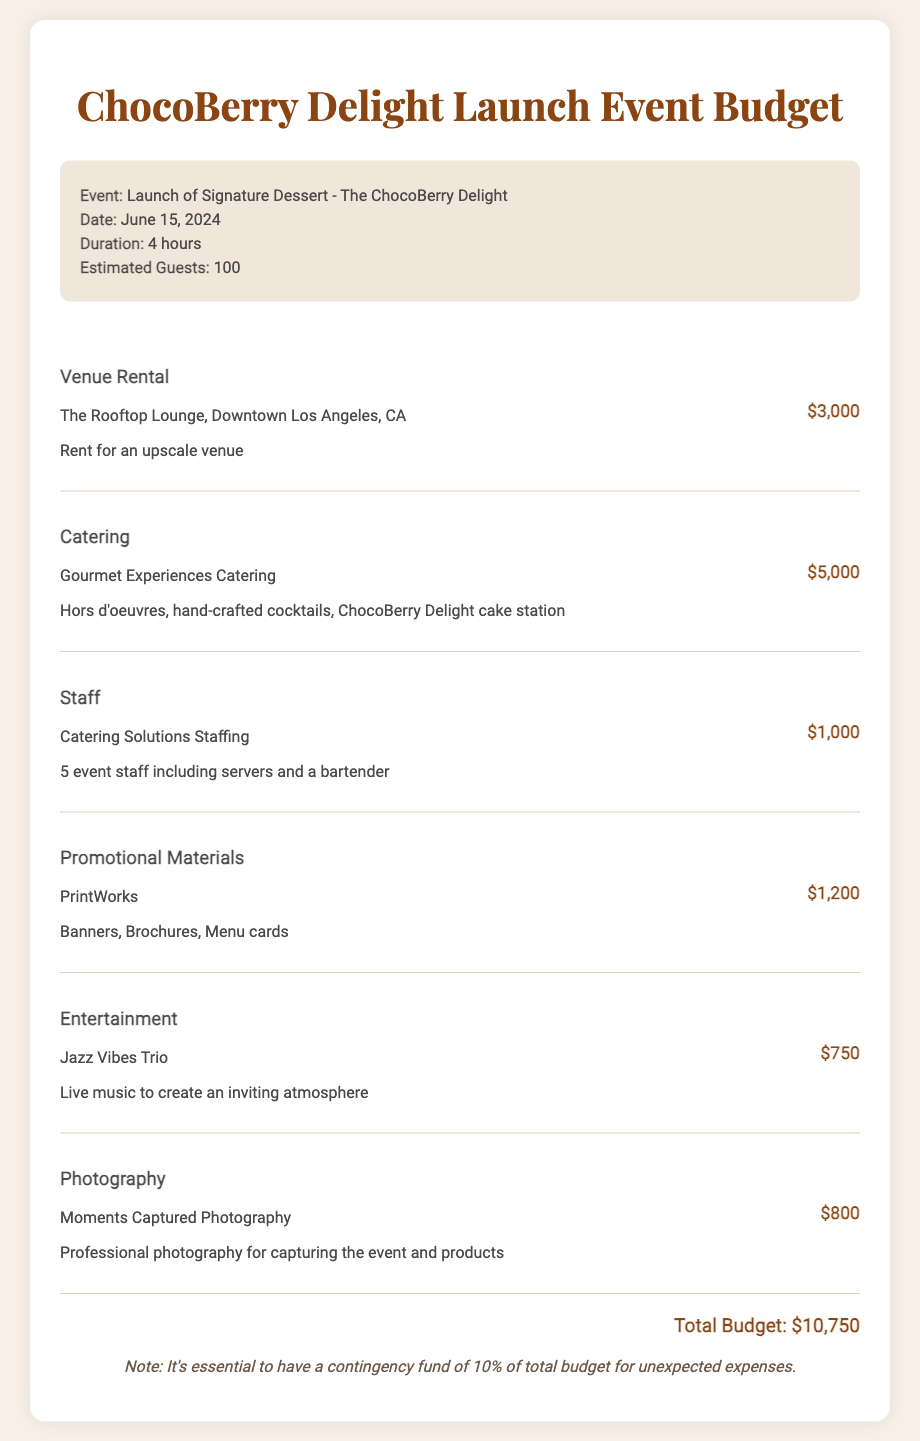What is the name of the signature dessert? The document states that the signature dessert being launched is called "ChocoBerry Delight."
Answer: ChocoBerry Delight What is the venue for the launch event? The document specifies that the venue for the launch event is "The Rooftop Lounge, Downtown Los Angeles, CA."
Answer: The Rooftop Lounge How much is allocated for catering? The budget for catering is mentioned as "$5,000."
Answer: $5,000 What is the date of the event? The document lists the date of the event as "June 15, 2024."
Answer: June 15, 2024 How many guests are estimated to attend? The estimated number of guests indicated in the document is "100."
Answer: 100 What is the total budget for the event? The document calculates the total budget for the event as "$10,750."
Answer: $10,750 How many event staff members will be present? The budget specifies that there will be "5 event staff" including servers and a bartender.
Answer: 5 What percentage of the total budget is recommended for a contingency fund? The document notes that a contingency fund of "10%" of the total budget is essential.
Answer: 10% How much is budgeted for entertainment? The budget shows a cost of "$750" for the entertainment by Jazz Vibes Trio.
Answer: $750 